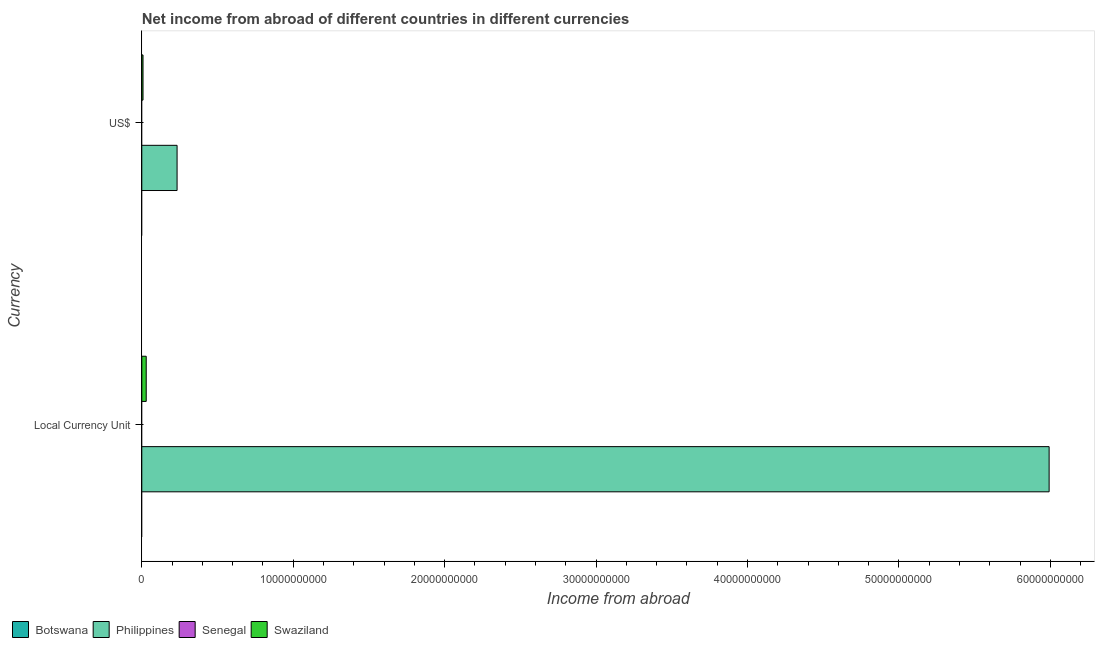Are the number of bars on each tick of the Y-axis equal?
Offer a very short reply. Yes. How many bars are there on the 2nd tick from the top?
Give a very brief answer. 2. What is the label of the 2nd group of bars from the top?
Your answer should be very brief. Local Currency Unit. What is the income from abroad in us$ in Philippines?
Make the answer very short. 2.33e+09. Across all countries, what is the maximum income from abroad in us$?
Provide a short and direct response. 2.33e+09. In which country was the income from abroad in us$ maximum?
Your answer should be compact. Philippines. What is the total income from abroad in constant 2005 us$ in the graph?
Keep it short and to the point. 6.02e+1. What is the difference between the income from abroad in constant 2005 us$ in Swaziland and that in Philippines?
Ensure brevity in your answer.  -5.96e+1. What is the difference between the income from abroad in us$ in Swaziland and the income from abroad in constant 2005 us$ in Philippines?
Your response must be concise. -5.98e+1. What is the average income from abroad in us$ per country?
Your response must be concise. 6.03e+08. What is the difference between the income from abroad in constant 2005 us$ and income from abroad in us$ in Swaziland?
Ensure brevity in your answer.  2.12e+08. In how many countries, is the income from abroad in us$ greater than 8000000000 units?
Make the answer very short. 0. What is the difference between two consecutive major ticks on the X-axis?
Your answer should be very brief. 1.00e+1. How are the legend labels stacked?
Offer a terse response. Horizontal. What is the title of the graph?
Provide a short and direct response. Net income from abroad of different countries in different currencies. What is the label or title of the X-axis?
Provide a short and direct response. Income from abroad. What is the label or title of the Y-axis?
Keep it short and to the point. Currency. What is the Income from abroad in Botswana in Local Currency Unit?
Provide a succinct answer. 0. What is the Income from abroad in Philippines in Local Currency Unit?
Give a very brief answer. 5.99e+1. What is the Income from abroad of Senegal in Local Currency Unit?
Offer a very short reply. 0. What is the Income from abroad in Swaziland in Local Currency Unit?
Your answer should be very brief. 2.92e+08. What is the Income from abroad in Botswana in US$?
Provide a succinct answer. 0. What is the Income from abroad of Philippines in US$?
Give a very brief answer. 2.33e+09. What is the Income from abroad in Senegal in US$?
Offer a terse response. 0. What is the Income from abroad in Swaziland in US$?
Provide a short and direct response. 8.05e+07. Across all Currency, what is the maximum Income from abroad in Philippines?
Provide a short and direct response. 5.99e+1. Across all Currency, what is the maximum Income from abroad of Swaziland?
Ensure brevity in your answer.  2.92e+08. Across all Currency, what is the minimum Income from abroad in Philippines?
Provide a short and direct response. 2.33e+09. Across all Currency, what is the minimum Income from abroad in Swaziland?
Offer a terse response. 8.05e+07. What is the total Income from abroad of Botswana in the graph?
Offer a terse response. 0. What is the total Income from abroad in Philippines in the graph?
Ensure brevity in your answer.  6.22e+1. What is the total Income from abroad in Swaziland in the graph?
Make the answer very short. 3.73e+08. What is the difference between the Income from abroad in Philippines in Local Currency Unit and that in US$?
Your response must be concise. 5.76e+1. What is the difference between the Income from abroad in Swaziland in Local Currency Unit and that in US$?
Provide a succinct answer. 2.12e+08. What is the difference between the Income from abroad in Philippines in Local Currency Unit and the Income from abroad in Swaziland in US$?
Offer a very short reply. 5.98e+1. What is the average Income from abroad of Botswana per Currency?
Offer a very short reply. 0. What is the average Income from abroad in Philippines per Currency?
Your answer should be compact. 3.11e+1. What is the average Income from abroad of Swaziland per Currency?
Make the answer very short. 1.86e+08. What is the difference between the Income from abroad in Philippines and Income from abroad in Swaziland in Local Currency Unit?
Provide a short and direct response. 5.96e+1. What is the difference between the Income from abroad in Philippines and Income from abroad in Swaziland in US$?
Your answer should be very brief. 2.25e+09. What is the ratio of the Income from abroad in Philippines in Local Currency Unit to that in US$?
Make the answer very short. 25.71. What is the ratio of the Income from abroad in Swaziland in Local Currency Unit to that in US$?
Your answer should be very brief. 3.63. What is the difference between the highest and the second highest Income from abroad of Philippines?
Give a very brief answer. 5.76e+1. What is the difference between the highest and the second highest Income from abroad of Swaziland?
Ensure brevity in your answer.  2.12e+08. What is the difference between the highest and the lowest Income from abroad in Philippines?
Make the answer very short. 5.76e+1. What is the difference between the highest and the lowest Income from abroad of Swaziland?
Keep it short and to the point. 2.12e+08. 